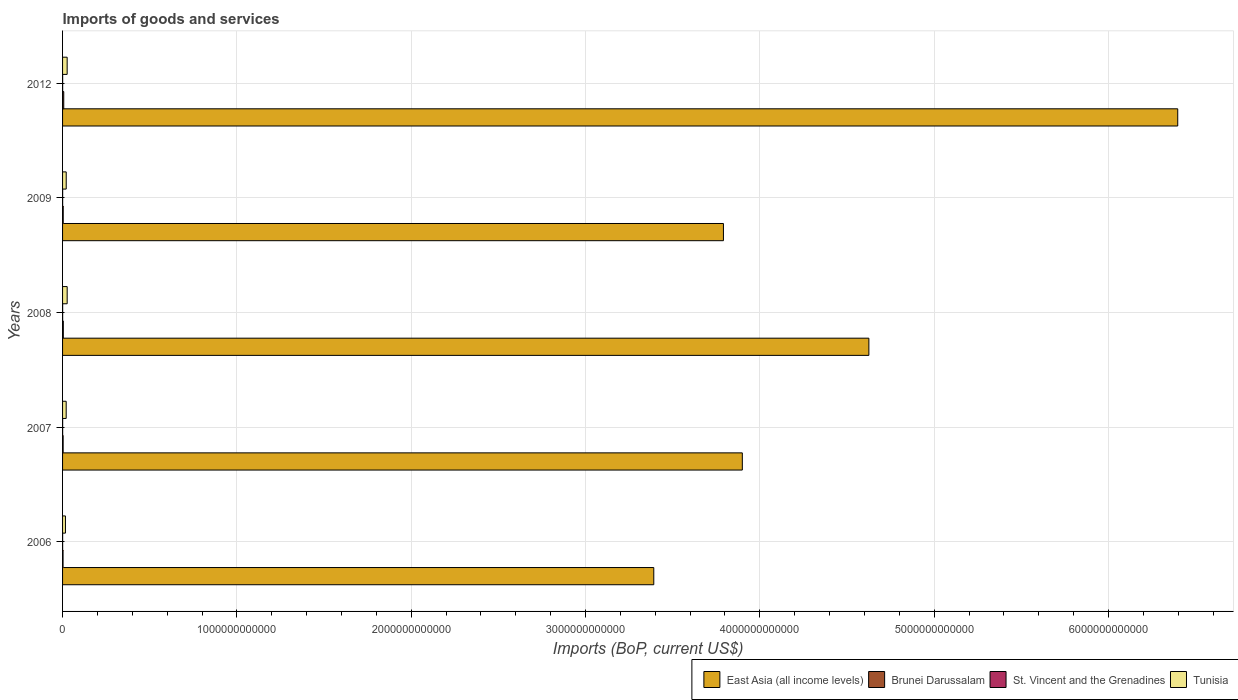How many different coloured bars are there?
Offer a very short reply. 4. How many groups of bars are there?
Your answer should be compact. 5. Are the number of bars per tick equal to the number of legend labels?
Offer a terse response. Yes. How many bars are there on the 5th tick from the bottom?
Your answer should be very brief. 4. What is the amount spent on imports in Tunisia in 2007?
Provide a short and direct response. 2.07e+1. Across all years, what is the maximum amount spent on imports in Tunisia?
Ensure brevity in your answer.  2.64e+1. Across all years, what is the minimum amount spent on imports in St. Vincent and the Grenadines?
Offer a terse response. 3.26e+08. In which year was the amount spent on imports in St. Vincent and the Grenadines minimum?
Your response must be concise. 2006. What is the total amount spent on imports in St. Vincent and the Grenadines in the graph?
Ensure brevity in your answer.  1.95e+09. What is the difference between the amount spent on imports in Tunisia in 2008 and that in 2009?
Your answer should be compact. 5.46e+09. What is the difference between the amount spent on imports in Brunei Darussalam in 2006 and the amount spent on imports in Tunisia in 2007?
Give a very brief answer. -1.79e+1. What is the average amount spent on imports in Tunisia per year?
Your answer should be compact. 2.22e+1. In the year 2007, what is the difference between the amount spent on imports in Brunei Darussalam and amount spent on imports in Tunisia?
Provide a short and direct response. -1.74e+1. In how many years, is the amount spent on imports in St. Vincent and the Grenadines greater than 5000000000000 US$?
Your answer should be compact. 0. What is the ratio of the amount spent on imports in East Asia (all income levels) in 2007 to that in 2009?
Your answer should be compact. 1.03. Is the amount spent on imports in Tunisia in 2008 less than that in 2009?
Provide a short and direct response. No. What is the difference between the highest and the second highest amount spent on imports in Brunei Darussalam?
Give a very brief answer. 2.50e+09. What is the difference between the highest and the lowest amount spent on imports in Brunei Darussalam?
Provide a short and direct response. 3.95e+09. Is it the case that in every year, the sum of the amount spent on imports in Brunei Darussalam and amount spent on imports in St. Vincent and the Grenadines is greater than the sum of amount spent on imports in East Asia (all income levels) and amount spent on imports in Tunisia?
Ensure brevity in your answer.  No. What does the 1st bar from the top in 2012 represents?
Your response must be concise. Tunisia. What does the 1st bar from the bottom in 2012 represents?
Keep it short and to the point. East Asia (all income levels). Is it the case that in every year, the sum of the amount spent on imports in Tunisia and amount spent on imports in East Asia (all income levels) is greater than the amount spent on imports in Brunei Darussalam?
Offer a terse response. Yes. How many bars are there?
Your answer should be very brief. 20. How many years are there in the graph?
Offer a terse response. 5. What is the difference between two consecutive major ticks on the X-axis?
Your answer should be very brief. 1.00e+12. Are the values on the major ticks of X-axis written in scientific E-notation?
Offer a terse response. No. Does the graph contain any zero values?
Your answer should be compact. No. Where does the legend appear in the graph?
Make the answer very short. Bottom right. How many legend labels are there?
Ensure brevity in your answer.  4. How are the legend labels stacked?
Keep it short and to the point. Horizontal. What is the title of the graph?
Keep it short and to the point. Imports of goods and services. What is the label or title of the X-axis?
Make the answer very short. Imports (BoP, current US$). What is the Imports (BoP, current US$) in East Asia (all income levels) in 2006?
Provide a short and direct response. 3.39e+12. What is the Imports (BoP, current US$) in Brunei Darussalam in 2006?
Ensure brevity in your answer.  2.80e+09. What is the Imports (BoP, current US$) in St. Vincent and the Grenadines in 2006?
Make the answer very short. 3.26e+08. What is the Imports (BoP, current US$) in Tunisia in 2006?
Give a very brief answer. 1.66e+1. What is the Imports (BoP, current US$) of East Asia (all income levels) in 2007?
Your answer should be compact. 3.90e+12. What is the Imports (BoP, current US$) in Brunei Darussalam in 2007?
Keep it short and to the point. 3.31e+09. What is the Imports (BoP, current US$) of St. Vincent and the Grenadines in 2007?
Ensure brevity in your answer.  4.02e+08. What is the Imports (BoP, current US$) of Tunisia in 2007?
Give a very brief answer. 2.07e+1. What is the Imports (BoP, current US$) of East Asia (all income levels) in 2008?
Your response must be concise. 4.63e+12. What is the Imports (BoP, current US$) in Brunei Darussalam in 2008?
Your answer should be compact. 4.26e+09. What is the Imports (BoP, current US$) of St. Vincent and the Grenadines in 2008?
Your answer should be very brief. 4.31e+08. What is the Imports (BoP, current US$) in Tunisia in 2008?
Keep it short and to the point. 2.64e+1. What is the Imports (BoP, current US$) of East Asia (all income levels) in 2009?
Your answer should be compact. 3.79e+12. What is the Imports (BoP, current US$) in Brunei Darussalam in 2009?
Your answer should be compact. 3.72e+09. What is the Imports (BoP, current US$) of St. Vincent and the Grenadines in 2009?
Offer a terse response. 3.88e+08. What is the Imports (BoP, current US$) in Tunisia in 2009?
Provide a short and direct response. 2.10e+1. What is the Imports (BoP, current US$) of East Asia (all income levels) in 2012?
Keep it short and to the point. 6.40e+12. What is the Imports (BoP, current US$) in Brunei Darussalam in 2012?
Your answer should be compact. 6.76e+09. What is the Imports (BoP, current US$) in St. Vincent and the Grenadines in 2012?
Your answer should be compact. 4.02e+08. What is the Imports (BoP, current US$) of Tunisia in 2012?
Provide a short and direct response. 2.63e+1. Across all years, what is the maximum Imports (BoP, current US$) in East Asia (all income levels)?
Provide a short and direct response. 6.40e+12. Across all years, what is the maximum Imports (BoP, current US$) in Brunei Darussalam?
Your answer should be very brief. 6.76e+09. Across all years, what is the maximum Imports (BoP, current US$) in St. Vincent and the Grenadines?
Offer a terse response. 4.31e+08. Across all years, what is the maximum Imports (BoP, current US$) in Tunisia?
Your answer should be very brief. 2.64e+1. Across all years, what is the minimum Imports (BoP, current US$) in East Asia (all income levels)?
Your response must be concise. 3.39e+12. Across all years, what is the minimum Imports (BoP, current US$) in Brunei Darussalam?
Your answer should be compact. 2.80e+09. Across all years, what is the minimum Imports (BoP, current US$) in St. Vincent and the Grenadines?
Keep it short and to the point. 3.26e+08. Across all years, what is the minimum Imports (BoP, current US$) of Tunisia?
Ensure brevity in your answer.  1.66e+1. What is the total Imports (BoP, current US$) in East Asia (all income levels) in the graph?
Your answer should be very brief. 2.21e+13. What is the total Imports (BoP, current US$) of Brunei Darussalam in the graph?
Your answer should be very brief. 2.08e+1. What is the total Imports (BoP, current US$) of St. Vincent and the Grenadines in the graph?
Make the answer very short. 1.95e+09. What is the total Imports (BoP, current US$) in Tunisia in the graph?
Offer a terse response. 1.11e+11. What is the difference between the Imports (BoP, current US$) in East Asia (all income levels) in 2006 and that in 2007?
Keep it short and to the point. -5.08e+11. What is the difference between the Imports (BoP, current US$) in Brunei Darussalam in 2006 and that in 2007?
Offer a terse response. -5.07e+08. What is the difference between the Imports (BoP, current US$) of St. Vincent and the Grenadines in 2006 and that in 2007?
Provide a succinct answer. -7.63e+07. What is the difference between the Imports (BoP, current US$) in Tunisia in 2006 and that in 2007?
Make the answer very short. -4.17e+09. What is the difference between the Imports (BoP, current US$) of East Asia (all income levels) in 2006 and that in 2008?
Your answer should be compact. -1.23e+12. What is the difference between the Imports (BoP, current US$) in Brunei Darussalam in 2006 and that in 2008?
Your answer should be very brief. -1.46e+09. What is the difference between the Imports (BoP, current US$) of St. Vincent and the Grenadines in 2006 and that in 2008?
Offer a very short reply. -1.05e+08. What is the difference between the Imports (BoP, current US$) of Tunisia in 2006 and that in 2008?
Keep it short and to the point. -9.88e+09. What is the difference between the Imports (BoP, current US$) in East Asia (all income levels) in 2006 and that in 2009?
Provide a succinct answer. -4.00e+11. What is the difference between the Imports (BoP, current US$) of Brunei Darussalam in 2006 and that in 2009?
Ensure brevity in your answer.  -9.15e+08. What is the difference between the Imports (BoP, current US$) in St. Vincent and the Grenadines in 2006 and that in 2009?
Provide a short and direct response. -6.22e+07. What is the difference between the Imports (BoP, current US$) in Tunisia in 2006 and that in 2009?
Keep it short and to the point. -4.43e+09. What is the difference between the Imports (BoP, current US$) of East Asia (all income levels) in 2006 and that in 2012?
Your response must be concise. -3.01e+12. What is the difference between the Imports (BoP, current US$) of Brunei Darussalam in 2006 and that in 2012?
Offer a very short reply. -3.95e+09. What is the difference between the Imports (BoP, current US$) of St. Vincent and the Grenadines in 2006 and that in 2012?
Provide a short and direct response. -7.62e+07. What is the difference between the Imports (BoP, current US$) in Tunisia in 2006 and that in 2012?
Make the answer very short. -9.73e+09. What is the difference between the Imports (BoP, current US$) of East Asia (all income levels) in 2007 and that in 2008?
Your answer should be compact. -7.26e+11. What is the difference between the Imports (BoP, current US$) of Brunei Darussalam in 2007 and that in 2008?
Offer a terse response. -9.52e+08. What is the difference between the Imports (BoP, current US$) in St. Vincent and the Grenadines in 2007 and that in 2008?
Make the answer very short. -2.87e+07. What is the difference between the Imports (BoP, current US$) of Tunisia in 2007 and that in 2008?
Keep it short and to the point. -5.71e+09. What is the difference between the Imports (BoP, current US$) of East Asia (all income levels) in 2007 and that in 2009?
Your answer should be compact. 1.08e+11. What is the difference between the Imports (BoP, current US$) of Brunei Darussalam in 2007 and that in 2009?
Your answer should be very brief. -4.08e+08. What is the difference between the Imports (BoP, current US$) in St. Vincent and the Grenadines in 2007 and that in 2009?
Offer a very short reply. 1.41e+07. What is the difference between the Imports (BoP, current US$) of Tunisia in 2007 and that in 2009?
Your answer should be compact. -2.56e+08. What is the difference between the Imports (BoP, current US$) of East Asia (all income levels) in 2007 and that in 2012?
Your answer should be compact. -2.50e+12. What is the difference between the Imports (BoP, current US$) of Brunei Darussalam in 2007 and that in 2012?
Provide a succinct answer. -3.45e+09. What is the difference between the Imports (BoP, current US$) in St. Vincent and the Grenadines in 2007 and that in 2012?
Ensure brevity in your answer.  1.83e+04. What is the difference between the Imports (BoP, current US$) of Tunisia in 2007 and that in 2012?
Your answer should be compact. -5.56e+09. What is the difference between the Imports (BoP, current US$) in East Asia (all income levels) in 2008 and that in 2009?
Provide a succinct answer. 8.34e+11. What is the difference between the Imports (BoP, current US$) in Brunei Darussalam in 2008 and that in 2009?
Offer a very short reply. 5.44e+08. What is the difference between the Imports (BoP, current US$) in St. Vincent and the Grenadines in 2008 and that in 2009?
Give a very brief answer. 4.28e+07. What is the difference between the Imports (BoP, current US$) of Tunisia in 2008 and that in 2009?
Your answer should be very brief. 5.46e+09. What is the difference between the Imports (BoP, current US$) of East Asia (all income levels) in 2008 and that in 2012?
Make the answer very short. -1.77e+12. What is the difference between the Imports (BoP, current US$) of Brunei Darussalam in 2008 and that in 2012?
Your answer should be very brief. -2.50e+09. What is the difference between the Imports (BoP, current US$) of St. Vincent and the Grenadines in 2008 and that in 2012?
Keep it short and to the point. 2.87e+07. What is the difference between the Imports (BoP, current US$) in Tunisia in 2008 and that in 2012?
Your response must be concise. 1.49e+08. What is the difference between the Imports (BoP, current US$) of East Asia (all income levels) in 2009 and that in 2012?
Your response must be concise. -2.61e+12. What is the difference between the Imports (BoP, current US$) of Brunei Darussalam in 2009 and that in 2012?
Make the answer very short. -3.04e+09. What is the difference between the Imports (BoP, current US$) in St. Vincent and the Grenadines in 2009 and that in 2012?
Your answer should be very brief. -1.41e+07. What is the difference between the Imports (BoP, current US$) in Tunisia in 2009 and that in 2012?
Ensure brevity in your answer.  -5.31e+09. What is the difference between the Imports (BoP, current US$) in East Asia (all income levels) in 2006 and the Imports (BoP, current US$) in Brunei Darussalam in 2007?
Provide a succinct answer. 3.39e+12. What is the difference between the Imports (BoP, current US$) of East Asia (all income levels) in 2006 and the Imports (BoP, current US$) of St. Vincent and the Grenadines in 2007?
Your answer should be very brief. 3.39e+12. What is the difference between the Imports (BoP, current US$) in East Asia (all income levels) in 2006 and the Imports (BoP, current US$) in Tunisia in 2007?
Offer a terse response. 3.37e+12. What is the difference between the Imports (BoP, current US$) of Brunei Darussalam in 2006 and the Imports (BoP, current US$) of St. Vincent and the Grenadines in 2007?
Your response must be concise. 2.40e+09. What is the difference between the Imports (BoP, current US$) in Brunei Darussalam in 2006 and the Imports (BoP, current US$) in Tunisia in 2007?
Give a very brief answer. -1.79e+1. What is the difference between the Imports (BoP, current US$) in St. Vincent and the Grenadines in 2006 and the Imports (BoP, current US$) in Tunisia in 2007?
Make the answer very short. -2.04e+1. What is the difference between the Imports (BoP, current US$) in East Asia (all income levels) in 2006 and the Imports (BoP, current US$) in Brunei Darussalam in 2008?
Your response must be concise. 3.39e+12. What is the difference between the Imports (BoP, current US$) in East Asia (all income levels) in 2006 and the Imports (BoP, current US$) in St. Vincent and the Grenadines in 2008?
Make the answer very short. 3.39e+12. What is the difference between the Imports (BoP, current US$) of East Asia (all income levels) in 2006 and the Imports (BoP, current US$) of Tunisia in 2008?
Offer a very short reply. 3.37e+12. What is the difference between the Imports (BoP, current US$) in Brunei Darussalam in 2006 and the Imports (BoP, current US$) in St. Vincent and the Grenadines in 2008?
Make the answer very short. 2.37e+09. What is the difference between the Imports (BoP, current US$) in Brunei Darussalam in 2006 and the Imports (BoP, current US$) in Tunisia in 2008?
Provide a succinct answer. -2.36e+1. What is the difference between the Imports (BoP, current US$) of St. Vincent and the Grenadines in 2006 and the Imports (BoP, current US$) of Tunisia in 2008?
Provide a succinct answer. -2.61e+1. What is the difference between the Imports (BoP, current US$) of East Asia (all income levels) in 2006 and the Imports (BoP, current US$) of Brunei Darussalam in 2009?
Provide a short and direct response. 3.39e+12. What is the difference between the Imports (BoP, current US$) in East Asia (all income levels) in 2006 and the Imports (BoP, current US$) in St. Vincent and the Grenadines in 2009?
Make the answer very short. 3.39e+12. What is the difference between the Imports (BoP, current US$) in East Asia (all income levels) in 2006 and the Imports (BoP, current US$) in Tunisia in 2009?
Make the answer very short. 3.37e+12. What is the difference between the Imports (BoP, current US$) of Brunei Darussalam in 2006 and the Imports (BoP, current US$) of St. Vincent and the Grenadines in 2009?
Offer a terse response. 2.41e+09. What is the difference between the Imports (BoP, current US$) in Brunei Darussalam in 2006 and the Imports (BoP, current US$) in Tunisia in 2009?
Your answer should be very brief. -1.82e+1. What is the difference between the Imports (BoP, current US$) in St. Vincent and the Grenadines in 2006 and the Imports (BoP, current US$) in Tunisia in 2009?
Offer a very short reply. -2.07e+1. What is the difference between the Imports (BoP, current US$) of East Asia (all income levels) in 2006 and the Imports (BoP, current US$) of Brunei Darussalam in 2012?
Offer a terse response. 3.38e+12. What is the difference between the Imports (BoP, current US$) in East Asia (all income levels) in 2006 and the Imports (BoP, current US$) in St. Vincent and the Grenadines in 2012?
Your answer should be very brief. 3.39e+12. What is the difference between the Imports (BoP, current US$) in East Asia (all income levels) in 2006 and the Imports (BoP, current US$) in Tunisia in 2012?
Your response must be concise. 3.37e+12. What is the difference between the Imports (BoP, current US$) in Brunei Darussalam in 2006 and the Imports (BoP, current US$) in St. Vincent and the Grenadines in 2012?
Make the answer very short. 2.40e+09. What is the difference between the Imports (BoP, current US$) of Brunei Darussalam in 2006 and the Imports (BoP, current US$) of Tunisia in 2012?
Offer a terse response. -2.35e+1. What is the difference between the Imports (BoP, current US$) in St. Vincent and the Grenadines in 2006 and the Imports (BoP, current US$) in Tunisia in 2012?
Provide a succinct answer. -2.60e+1. What is the difference between the Imports (BoP, current US$) of East Asia (all income levels) in 2007 and the Imports (BoP, current US$) of Brunei Darussalam in 2008?
Your answer should be compact. 3.90e+12. What is the difference between the Imports (BoP, current US$) of East Asia (all income levels) in 2007 and the Imports (BoP, current US$) of St. Vincent and the Grenadines in 2008?
Your answer should be compact. 3.90e+12. What is the difference between the Imports (BoP, current US$) of East Asia (all income levels) in 2007 and the Imports (BoP, current US$) of Tunisia in 2008?
Keep it short and to the point. 3.87e+12. What is the difference between the Imports (BoP, current US$) of Brunei Darussalam in 2007 and the Imports (BoP, current US$) of St. Vincent and the Grenadines in 2008?
Keep it short and to the point. 2.88e+09. What is the difference between the Imports (BoP, current US$) of Brunei Darussalam in 2007 and the Imports (BoP, current US$) of Tunisia in 2008?
Ensure brevity in your answer.  -2.31e+1. What is the difference between the Imports (BoP, current US$) in St. Vincent and the Grenadines in 2007 and the Imports (BoP, current US$) in Tunisia in 2008?
Ensure brevity in your answer.  -2.60e+1. What is the difference between the Imports (BoP, current US$) in East Asia (all income levels) in 2007 and the Imports (BoP, current US$) in Brunei Darussalam in 2009?
Your answer should be very brief. 3.90e+12. What is the difference between the Imports (BoP, current US$) of East Asia (all income levels) in 2007 and the Imports (BoP, current US$) of St. Vincent and the Grenadines in 2009?
Make the answer very short. 3.90e+12. What is the difference between the Imports (BoP, current US$) of East Asia (all income levels) in 2007 and the Imports (BoP, current US$) of Tunisia in 2009?
Give a very brief answer. 3.88e+12. What is the difference between the Imports (BoP, current US$) of Brunei Darussalam in 2007 and the Imports (BoP, current US$) of St. Vincent and the Grenadines in 2009?
Your response must be concise. 2.92e+09. What is the difference between the Imports (BoP, current US$) in Brunei Darussalam in 2007 and the Imports (BoP, current US$) in Tunisia in 2009?
Your answer should be compact. -1.77e+1. What is the difference between the Imports (BoP, current US$) of St. Vincent and the Grenadines in 2007 and the Imports (BoP, current US$) of Tunisia in 2009?
Your answer should be compact. -2.06e+1. What is the difference between the Imports (BoP, current US$) in East Asia (all income levels) in 2007 and the Imports (BoP, current US$) in Brunei Darussalam in 2012?
Provide a short and direct response. 3.89e+12. What is the difference between the Imports (BoP, current US$) of East Asia (all income levels) in 2007 and the Imports (BoP, current US$) of St. Vincent and the Grenadines in 2012?
Provide a short and direct response. 3.90e+12. What is the difference between the Imports (BoP, current US$) in East Asia (all income levels) in 2007 and the Imports (BoP, current US$) in Tunisia in 2012?
Ensure brevity in your answer.  3.87e+12. What is the difference between the Imports (BoP, current US$) of Brunei Darussalam in 2007 and the Imports (BoP, current US$) of St. Vincent and the Grenadines in 2012?
Your response must be concise. 2.91e+09. What is the difference between the Imports (BoP, current US$) of Brunei Darussalam in 2007 and the Imports (BoP, current US$) of Tunisia in 2012?
Your answer should be compact. -2.30e+1. What is the difference between the Imports (BoP, current US$) of St. Vincent and the Grenadines in 2007 and the Imports (BoP, current US$) of Tunisia in 2012?
Offer a very short reply. -2.59e+1. What is the difference between the Imports (BoP, current US$) of East Asia (all income levels) in 2008 and the Imports (BoP, current US$) of Brunei Darussalam in 2009?
Make the answer very short. 4.62e+12. What is the difference between the Imports (BoP, current US$) of East Asia (all income levels) in 2008 and the Imports (BoP, current US$) of St. Vincent and the Grenadines in 2009?
Ensure brevity in your answer.  4.63e+12. What is the difference between the Imports (BoP, current US$) of East Asia (all income levels) in 2008 and the Imports (BoP, current US$) of Tunisia in 2009?
Your answer should be compact. 4.60e+12. What is the difference between the Imports (BoP, current US$) of Brunei Darussalam in 2008 and the Imports (BoP, current US$) of St. Vincent and the Grenadines in 2009?
Your response must be concise. 3.87e+09. What is the difference between the Imports (BoP, current US$) in Brunei Darussalam in 2008 and the Imports (BoP, current US$) in Tunisia in 2009?
Keep it short and to the point. -1.67e+1. What is the difference between the Imports (BoP, current US$) in St. Vincent and the Grenadines in 2008 and the Imports (BoP, current US$) in Tunisia in 2009?
Make the answer very short. -2.06e+1. What is the difference between the Imports (BoP, current US$) in East Asia (all income levels) in 2008 and the Imports (BoP, current US$) in Brunei Darussalam in 2012?
Your response must be concise. 4.62e+12. What is the difference between the Imports (BoP, current US$) in East Asia (all income levels) in 2008 and the Imports (BoP, current US$) in St. Vincent and the Grenadines in 2012?
Your answer should be compact. 4.63e+12. What is the difference between the Imports (BoP, current US$) in East Asia (all income levels) in 2008 and the Imports (BoP, current US$) in Tunisia in 2012?
Offer a terse response. 4.60e+12. What is the difference between the Imports (BoP, current US$) of Brunei Darussalam in 2008 and the Imports (BoP, current US$) of St. Vincent and the Grenadines in 2012?
Your answer should be very brief. 3.86e+09. What is the difference between the Imports (BoP, current US$) in Brunei Darussalam in 2008 and the Imports (BoP, current US$) in Tunisia in 2012?
Keep it short and to the point. -2.20e+1. What is the difference between the Imports (BoP, current US$) of St. Vincent and the Grenadines in 2008 and the Imports (BoP, current US$) of Tunisia in 2012?
Offer a terse response. -2.59e+1. What is the difference between the Imports (BoP, current US$) of East Asia (all income levels) in 2009 and the Imports (BoP, current US$) of Brunei Darussalam in 2012?
Your answer should be compact. 3.78e+12. What is the difference between the Imports (BoP, current US$) in East Asia (all income levels) in 2009 and the Imports (BoP, current US$) in St. Vincent and the Grenadines in 2012?
Provide a short and direct response. 3.79e+12. What is the difference between the Imports (BoP, current US$) of East Asia (all income levels) in 2009 and the Imports (BoP, current US$) of Tunisia in 2012?
Offer a terse response. 3.76e+12. What is the difference between the Imports (BoP, current US$) of Brunei Darussalam in 2009 and the Imports (BoP, current US$) of St. Vincent and the Grenadines in 2012?
Offer a very short reply. 3.31e+09. What is the difference between the Imports (BoP, current US$) in Brunei Darussalam in 2009 and the Imports (BoP, current US$) in Tunisia in 2012?
Your answer should be very brief. -2.26e+1. What is the difference between the Imports (BoP, current US$) in St. Vincent and the Grenadines in 2009 and the Imports (BoP, current US$) in Tunisia in 2012?
Ensure brevity in your answer.  -2.59e+1. What is the average Imports (BoP, current US$) in East Asia (all income levels) per year?
Provide a succinct answer. 4.42e+12. What is the average Imports (BoP, current US$) of Brunei Darussalam per year?
Your answer should be very brief. 4.17e+09. What is the average Imports (BoP, current US$) in St. Vincent and the Grenadines per year?
Provide a short and direct response. 3.90e+08. What is the average Imports (BoP, current US$) of Tunisia per year?
Provide a short and direct response. 2.22e+1. In the year 2006, what is the difference between the Imports (BoP, current US$) in East Asia (all income levels) and Imports (BoP, current US$) in Brunei Darussalam?
Keep it short and to the point. 3.39e+12. In the year 2006, what is the difference between the Imports (BoP, current US$) in East Asia (all income levels) and Imports (BoP, current US$) in St. Vincent and the Grenadines?
Provide a short and direct response. 3.39e+12. In the year 2006, what is the difference between the Imports (BoP, current US$) of East Asia (all income levels) and Imports (BoP, current US$) of Tunisia?
Offer a terse response. 3.37e+12. In the year 2006, what is the difference between the Imports (BoP, current US$) in Brunei Darussalam and Imports (BoP, current US$) in St. Vincent and the Grenadines?
Your answer should be very brief. 2.48e+09. In the year 2006, what is the difference between the Imports (BoP, current US$) in Brunei Darussalam and Imports (BoP, current US$) in Tunisia?
Provide a short and direct response. -1.38e+1. In the year 2006, what is the difference between the Imports (BoP, current US$) of St. Vincent and the Grenadines and Imports (BoP, current US$) of Tunisia?
Make the answer very short. -1.62e+1. In the year 2007, what is the difference between the Imports (BoP, current US$) in East Asia (all income levels) and Imports (BoP, current US$) in Brunei Darussalam?
Provide a succinct answer. 3.90e+12. In the year 2007, what is the difference between the Imports (BoP, current US$) of East Asia (all income levels) and Imports (BoP, current US$) of St. Vincent and the Grenadines?
Your answer should be compact. 3.90e+12. In the year 2007, what is the difference between the Imports (BoP, current US$) of East Asia (all income levels) and Imports (BoP, current US$) of Tunisia?
Your answer should be compact. 3.88e+12. In the year 2007, what is the difference between the Imports (BoP, current US$) of Brunei Darussalam and Imports (BoP, current US$) of St. Vincent and the Grenadines?
Make the answer very short. 2.91e+09. In the year 2007, what is the difference between the Imports (BoP, current US$) of Brunei Darussalam and Imports (BoP, current US$) of Tunisia?
Offer a very short reply. -1.74e+1. In the year 2007, what is the difference between the Imports (BoP, current US$) of St. Vincent and the Grenadines and Imports (BoP, current US$) of Tunisia?
Your response must be concise. -2.03e+1. In the year 2008, what is the difference between the Imports (BoP, current US$) of East Asia (all income levels) and Imports (BoP, current US$) of Brunei Darussalam?
Ensure brevity in your answer.  4.62e+12. In the year 2008, what is the difference between the Imports (BoP, current US$) in East Asia (all income levels) and Imports (BoP, current US$) in St. Vincent and the Grenadines?
Make the answer very short. 4.63e+12. In the year 2008, what is the difference between the Imports (BoP, current US$) of East Asia (all income levels) and Imports (BoP, current US$) of Tunisia?
Offer a very short reply. 4.60e+12. In the year 2008, what is the difference between the Imports (BoP, current US$) in Brunei Darussalam and Imports (BoP, current US$) in St. Vincent and the Grenadines?
Keep it short and to the point. 3.83e+09. In the year 2008, what is the difference between the Imports (BoP, current US$) in Brunei Darussalam and Imports (BoP, current US$) in Tunisia?
Offer a terse response. -2.22e+1. In the year 2008, what is the difference between the Imports (BoP, current US$) of St. Vincent and the Grenadines and Imports (BoP, current US$) of Tunisia?
Make the answer very short. -2.60e+1. In the year 2009, what is the difference between the Imports (BoP, current US$) of East Asia (all income levels) and Imports (BoP, current US$) of Brunei Darussalam?
Your response must be concise. 3.79e+12. In the year 2009, what is the difference between the Imports (BoP, current US$) in East Asia (all income levels) and Imports (BoP, current US$) in St. Vincent and the Grenadines?
Your answer should be very brief. 3.79e+12. In the year 2009, what is the difference between the Imports (BoP, current US$) of East Asia (all income levels) and Imports (BoP, current US$) of Tunisia?
Provide a short and direct response. 3.77e+12. In the year 2009, what is the difference between the Imports (BoP, current US$) of Brunei Darussalam and Imports (BoP, current US$) of St. Vincent and the Grenadines?
Ensure brevity in your answer.  3.33e+09. In the year 2009, what is the difference between the Imports (BoP, current US$) in Brunei Darussalam and Imports (BoP, current US$) in Tunisia?
Offer a very short reply. -1.73e+1. In the year 2009, what is the difference between the Imports (BoP, current US$) in St. Vincent and the Grenadines and Imports (BoP, current US$) in Tunisia?
Give a very brief answer. -2.06e+1. In the year 2012, what is the difference between the Imports (BoP, current US$) of East Asia (all income levels) and Imports (BoP, current US$) of Brunei Darussalam?
Your response must be concise. 6.39e+12. In the year 2012, what is the difference between the Imports (BoP, current US$) in East Asia (all income levels) and Imports (BoP, current US$) in St. Vincent and the Grenadines?
Ensure brevity in your answer.  6.40e+12. In the year 2012, what is the difference between the Imports (BoP, current US$) of East Asia (all income levels) and Imports (BoP, current US$) of Tunisia?
Your answer should be compact. 6.37e+12. In the year 2012, what is the difference between the Imports (BoP, current US$) in Brunei Darussalam and Imports (BoP, current US$) in St. Vincent and the Grenadines?
Ensure brevity in your answer.  6.35e+09. In the year 2012, what is the difference between the Imports (BoP, current US$) of Brunei Darussalam and Imports (BoP, current US$) of Tunisia?
Give a very brief answer. -1.95e+1. In the year 2012, what is the difference between the Imports (BoP, current US$) in St. Vincent and the Grenadines and Imports (BoP, current US$) in Tunisia?
Make the answer very short. -2.59e+1. What is the ratio of the Imports (BoP, current US$) in East Asia (all income levels) in 2006 to that in 2007?
Provide a succinct answer. 0.87. What is the ratio of the Imports (BoP, current US$) of Brunei Darussalam in 2006 to that in 2007?
Offer a very short reply. 0.85. What is the ratio of the Imports (BoP, current US$) in St. Vincent and the Grenadines in 2006 to that in 2007?
Give a very brief answer. 0.81. What is the ratio of the Imports (BoP, current US$) in Tunisia in 2006 to that in 2007?
Offer a terse response. 0.8. What is the ratio of the Imports (BoP, current US$) in East Asia (all income levels) in 2006 to that in 2008?
Offer a very short reply. 0.73. What is the ratio of the Imports (BoP, current US$) of Brunei Darussalam in 2006 to that in 2008?
Your response must be concise. 0.66. What is the ratio of the Imports (BoP, current US$) in St. Vincent and the Grenadines in 2006 to that in 2008?
Provide a succinct answer. 0.76. What is the ratio of the Imports (BoP, current US$) of Tunisia in 2006 to that in 2008?
Make the answer very short. 0.63. What is the ratio of the Imports (BoP, current US$) of East Asia (all income levels) in 2006 to that in 2009?
Provide a succinct answer. 0.89. What is the ratio of the Imports (BoP, current US$) in Brunei Darussalam in 2006 to that in 2009?
Offer a terse response. 0.75. What is the ratio of the Imports (BoP, current US$) of St. Vincent and the Grenadines in 2006 to that in 2009?
Provide a succinct answer. 0.84. What is the ratio of the Imports (BoP, current US$) of Tunisia in 2006 to that in 2009?
Offer a terse response. 0.79. What is the ratio of the Imports (BoP, current US$) of East Asia (all income levels) in 2006 to that in 2012?
Your response must be concise. 0.53. What is the ratio of the Imports (BoP, current US$) in Brunei Darussalam in 2006 to that in 2012?
Ensure brevity in your answer.  0.41. What is the ratio of the Imports (BoP, current US$) in St. Vincent and the Grenadines in 2006 to that in 2012?
Offer a terse response. 0.81. What is the ratio of the Imports (BoP, current US$) in Tunisia in 2006 to that in 2012?
Ensure brevity in your answer.  0.63. What is the ratio of the Imports (BoP, current US$) in East Asia (all income levels) in 2007 to that in 2008?
Offer a terse response. 0.84. What is the ratio of the Imports (BoP, current US$) in Brunei Darussalam in 2007 to that in 2008?
Offer a terse response. 0.78. What is the ratio of the Imports (BoP, current US$) of St. Vincent and the Grenadines in 2007 to that in 2008?
Make the answer very short. 0.93. What is the ratio of the Imports (BoP, current US$) of Tunisia in 2007 to that in 2008?
Offer a very short reply. 0.78. What is the ratio of the Imports (BoP, current US$) in East Asia (all income levels) in 2007 to that in 2009?
Keep it short and to the point. 1.03. What is the ratio of the Imports (BoP, current US$) of Brunei Darussalam in 2007 to that in 2009?
Offer a terse response. 0.89. What is the ratio of the Imports (BoP, current US$) of St. Vincent and the Grenadines in 2007 to that in 2009?
Your answer should be compact. 1.04. What is the ratio of the Imports (BoP, current US$) in East Asia (all income levels) in 2007 to that in 2012?
Your answer should be very brief. 0.61. What is the ratio of the Imports (BoP, current US$) of Brunei Darussalam in 2007 to that in 2012?
Offer a terse response. 0.49. What is the ratio of the Imports (BoP, current US$) in Tunisia in 2007 to that in 2012?
Your answer should be compact. 0.79. What is the ratio of the Imports (BoP, current US$) of East Asia (all income levels) in 2008 to that in 2009?
Keep it short and to the point. 1.22. What is the ratio of the Imports (BoP, current US$) of Brunei Darussalam in 2008 to that in 2009?
Your response must be concise. 1.15. What is the ratio of the Imports (BoP, current US$) in St. Vincent and the Grenadines in 2008 to that in 2009?
Keep it short and to the point. 1.11. What is the ratio of the Imports (BoP, current US$) in Tunisia in 2008 to that in 2009?
Offer a very short reply. 1.26. What is the ratio of the Imports (BoP, current US$) of East Asia (all income levels) in 2008 to that in 2012?
Your answer should be compact. 0.72. What is the ratio of the Imports (BoP, current US$) in Brunei Darussalam in 2008 to that in 2012?
Provide a short and direct response. 0.63. What is the ratio of the Imports (BoP, current US$) in St. Vincent and the Grenadines in 2008 to that in 2012?
Offer a terse response. 1.07. What is the ratio of the Imports (BoP, current US$) of Tunisia in 2008 to that in 2012?
Give a very brief answer. 1.01. What is the ratio of the Imports (BoP, current US$) in East Asia (all income levels) in 2009 to that in 2012?
Keep it short and to the point. 0.59. What is the ratio of the Imports (BoP, current US$) in Brunei Darussalam in 2009 to that in 2012?
Offer a terse response. 0.55. What is the ratio of the Imports (BoP, current US$) in St. Vincent and the Grenadines in 2009 to that in 2012?
Your answer should be very brief. 0.96. What is the ratio of the Imports (BoP, current US$) of Tunisia in 2009 to that in 2012?
Give a very brief answer. 0.8. What is the difference between the highest and the second highest Imports (BoP, current US$) of East Asia (all income levels)?
Make the answer very short. 1.77e+12. What is the difference between the highest and the second highest Imports (BoP, current US$) of Brunei Darussalam?
Give a very brief answer. 2.50e+09. What is the difference between the highest and the second highest Imports (BoP, current US$) of St. Vincent and the Grenadines?
Offer a very short reply. 2.87e+07. What is the difference between the highest and the second highest Imports (BoP, current US$) in Tunisia?
Make the answer very short. 1.49e+08. What is the difference between the highest and the lowest Imports (BoP, current US$) of East Asia (all income levels)?
Your answer should be very brief. 3.01e+12. What is the difference between the highest and the lowest Imports (BoP, current US$) in Brunei Darussalam?
Make the answer very short. 3.95e+09. What is the difference between the highest and the lowest Imports (BoP, current US$) in St. Vincent and the Grenadines?
Provide a short and direct response. 1.05e+08. What is the difference between the highest and the lowest Imports (BoP, current US$) in Tunisia?
Provide a short and direct response. 9.88e+09. 